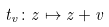<formula> <loc_0><loc_0><loc_500><loc_500>t _ { v } \colon z \mapsto z + v</formula> 